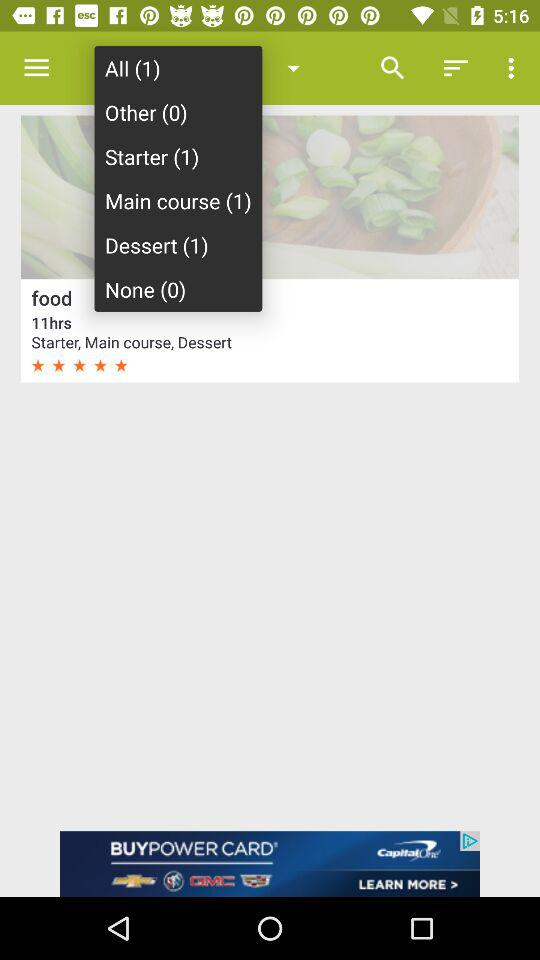What is the number of foods in a dessert? The number of foods in a dessert is 1. 